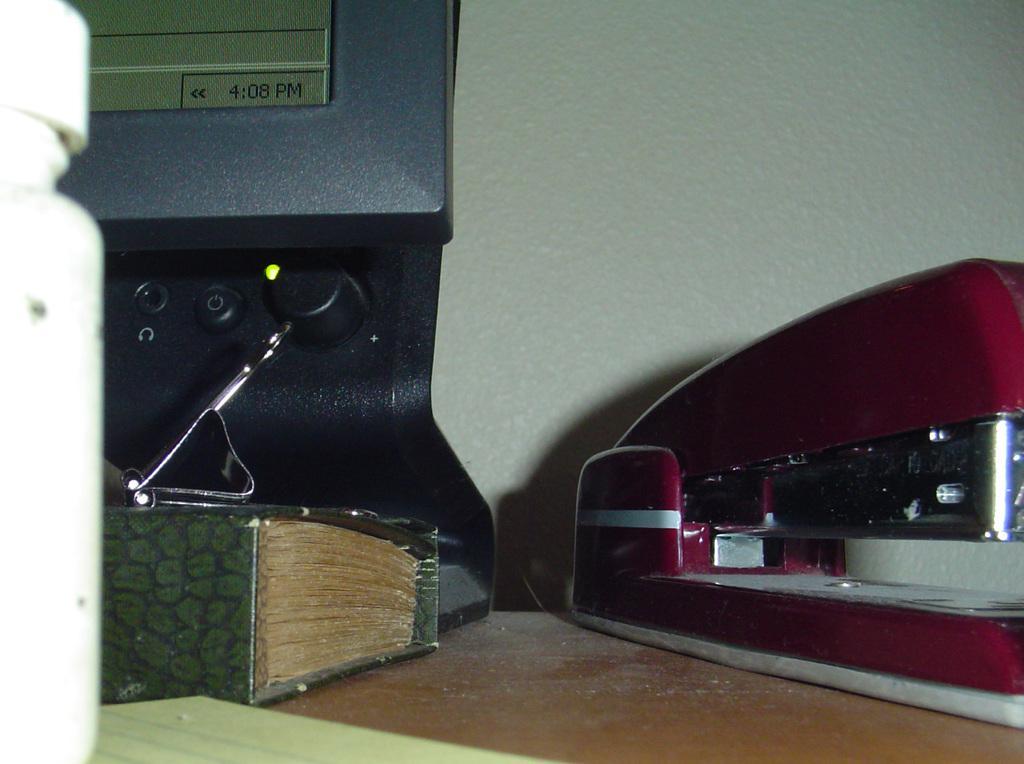Can you describe this image briefly? In this image there is a monitor, book and other objects placed on a table. 